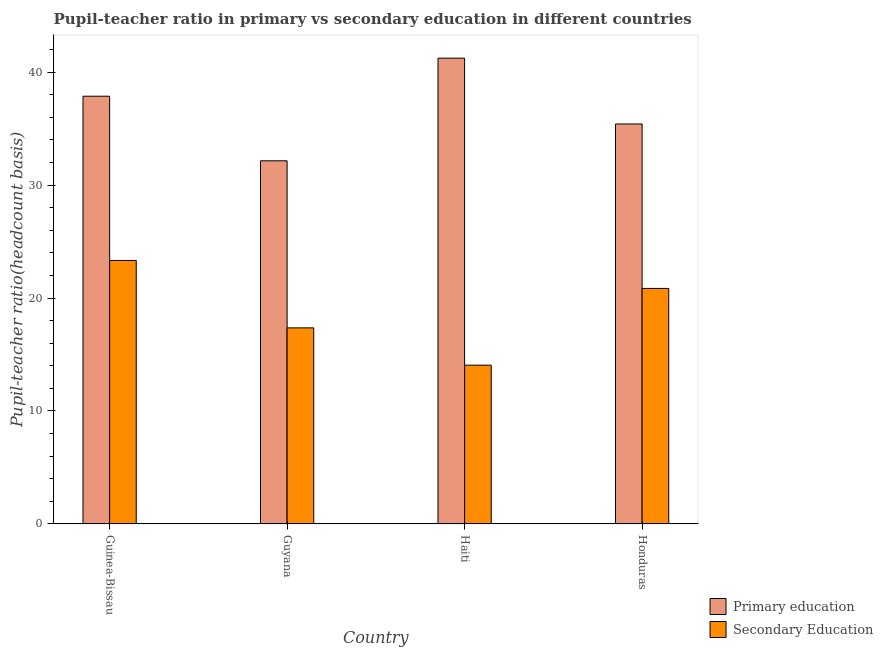How many bars are there on the 3rd tick from the left?
Provide a short and direct response. 2. What is the label of the 3rd group of bars from the left?
Provide a short and direct response. Haiti. In how many cases, is the number of bars for a given country not equal to the number of legend labels?
Provide a succinct answer. 0. What is the pupil-teacher ratio in primary education in Guinea-Bissau?
Provide a succinct answer. 37.86. Across all countries, what is the maximum pupil teacher ratio on secondary education?
Provide a short and direct response. 23.32. Across all countries, what is the minimum pupil teacher ratio on secondary education?
Offer a terse response. 14.06. In which country was the pupil teacher ratio on secondary education maximum?
Offer a terse response. Guinea-Bissau. In which country was the pupil teacher ratio on secondary education minimum?
Keep it short and to the point. Haiti. What is the total pupil-teacher ratio in primary education in the graph?
Ensure brevity in your answer.  146.63. What is the difference between the pupil teacher ratio on secondary education in Guinea-Bissau and that in Haiti?
Offer a very short reply. 9.27. What is the difference between the pupil-teacher ratio in primary education in Guyana and the pupil teacher ratio on secondary education in Honduras?
Provide a succinct answer. 11.29. What is the average pupil-teacher ratio in primary education per country?
Ensure brevity in your answer.  36.66. What is the difference between the pupil-teacher ratio in primary education and pupil teacher ratio on secondary education in Guyana?
Your response must be concise. 14.79. In how many countries, is the pupil teacher ratio on secondary education greater than 34 ?
Your answer should be compact. 0. What is the ratio of the pupil teacher ratio on secondary education in Guinea-Bissau to that in Haiti?
Keep it short and to the point. 1.66. Is the pupil teacher ratio on secondary education in Haiti less than that in Honduras?
Your answer should be very brief. Yes. What is the difference between the highest and the second highest pupil teacher ratio on secondary education?
Give a very brief answer. 2.47. What is the difference between the highest and the lowest pupil teacher ratio on secondary education?
Provide a short and direct response. 9.27. In how many countries, is the pupil teacher ratio on secondary education greater than the average pupil teacher ratio on secondary education taken over all countries?
Offer a very short reply. 2. Is the sum of the pupil teacher ratio on secondary education in Guyana and Haiti greater than the maximum pupil-teacher ratio in primary education across all countries?
Give a very brief answer. No. What does the 1st bar from the right in Haiti represents?
Keep it short and to the point. Secondary Education. How many bars are there?
Offer a very short reply. 8. How many countries are there in the graph?
Ensure brevity in your answer.  4. Are the values on the major ticks of Y-axis written in scientific E-notation?
Your answer should be compact. No. Does the graph contain any zero values?
Keep it short and to the point. No. Where does the legend appear in the graph?
Provide a succinct answer. Bottom right. How are the legend labels stacked?
Provide a short and direct response. Vertical. What is the title of the graph?
Give a very brief answer. Pupil-teacher ratio in primary vs secondary education in different countries. Does "Secondary education" appear as one of the legend labels in the graph?
Your answer should be compact. No. What is the label or title of the Y-axis?
Your response must be concise. Pupil-teacher ratio(headcount basis). What is the Pupil-teacher ratio(headcount basis) of Primary education in Guinea-Bissau?
Provide a succinct answer. 37.86. What is the Pupil-teacher ratio(headcount basis) in Secondary Education in Guinea-Bissau?
Offer a very short reply. 23.32. What is the Pupil-teacher ratio(headcount basis) of Primary education in Guyana?
Make the answer very short. 32.14. What is the Pupil-teacher ratio(headcount basis) in Secondary Education in Guyana?
Your answer should be compact. 17.36. What is the Pupil-teacher ratio(headcount basis) of Primary education in Haiti?
Offer a very short reply. 41.23. What is the Pupil-teacher ratio(headcount basis) of Secondary Education in Haiti?
Ensure brevity in your answer.  14.06. What is the Pupil-teacher ratio(headcount basis) of Primary education in Honduras?
Make the answer very short. 35.4. What is the Pupil-teacher ratio(headcount basis) of Secondary Education in Honduras?
Ensure brevity in your answer.  20.85. Across all countries, what is the maximum Pupil-teacher ratio(headcount basis) of Primary education?
Make the answer very short. 41.23. Across all countries, what is the maximum Pupil-teacher ratio(headcount basis) in Secondary Education?
Your answer should be very brief. 23.32. Across all countries, what is the minimum Pupil-teacher ratio(headcount basis) of Primary education?
Give a very brief answer. 32.14. Across all countries, what is the minimum Pupil-teacher ratio(headcount basis) in Secondary Education?
Make the answer very short. 14.06. What is the total Pupil-teacher ratio(headcount basis) of Primary education in the graph?
Offer a terse response. 146.63. What is the total Pupil-teacher ratio(headcount basis) of Secondary Education in the graph?
Provide a short and direct response. 75.58. What is the difference between the Pupil-teacher ratio(headcount basis) in Primary education in Guinea-Bissau and that in Guyana?
Make the answer very short. 5.72. What is the difference between the Pupil-teacher ratio(headcount basis) of Secondary Education in Guinea-Bissau and that in Guyana?
Offer a terse response. 5.97. What is the difference between the Pupil-teacher ratio(headcount basis) of Primary education in Guinea-Bissau and that in Haiti?
Your response must be concise. -3.37. What is the difference between the Pupil-teacher ratio(headcount basis) of Secondary Education in Guinea-Bissau and that in Haiti?
Keep it short and to the point. 9.27. What is the difference between the Pupil-teacher ratio(headcount basis) of Primary education in Guinea-Bissau and that in Honduras?
Ensure brevity in your answer.  2.46. What is the difference between the Pupil-teacher ratio(headcount basis) in Secondary Education in Guinea-Bissau and that in Honduras?
Provide a short and direct response. 2.47. What is the difference between the Pupil-teacher ratio(headcount basis) of Primary education in Guyana and that in Haiti?
Offer a terse response. -9.08. What is the difference between the Pupil-teacher ratio(headcount basis) of Secondary Education in Guyana and that in Haiti?
Provide a succinct answer. 3.3. What is the difference between the Pupil-teacher ratio(headcount basis) in Primary education in Guyana and that in Honduras?
Your answer should be compact. -3.26. What is the difference between the Pupil-teacher ratio(headcount basis) of Secondary Education in Guyana and that in Honduras?
Provide a short and direct response. -3.49. What is the difference between the Pupil-teacher ratio(headcount basis) in Primary education in Haiti and that in Honduras?
Provide a short and direct response. 5.82. What is the difference between the Pupil-teacher ratio(headcount basis) of Secondary Education in Haiti and that in Honduras?
Your response must be concise. -6.79. What is the difference between the Pupil-teacher ratio(headcount basis) in Primary education in Guinea-Bissau and the Pupil-teacher ratio(headcount basis) in Secondary Education in Guyana?
Your response must be concise. 20.5. What is the difference between the Pupil-teacher ratio(headcount basis) in Primary education in Guinea-Bissau and the Pupil-teacher ratio(headcount basis) in Secondary Education in Haiti?
Provide a short and direct response. 23.8. What is the difference between the Pupil-teacher ratio(headcount basis) in Primary education in Guinea-Bissau and the Pupil-teacher ratio(headcount basis) in Secondary Education in Honduras?
Your answer should be compact. 17.01. What is the difference between the Pupil-teacher ratio(headcount basis) of Primary education in Guyana and the Pupil-teacher ratio(headcount basis) of Secondary Education in Haiti?
Make the answer very short. 18.09. What is the difference between the Pupil-teacher ratio(headcount basis) of Primary education in Guyana and the Pupil-teacher ratio(headcount basis) of Secondary Education in Honduras?
Give a very brief answer. 11.29. What is the difference between the Pupil-teacher ratio(headcount basis) in Primary education in Haiti and the Pupil-teacher ratio(headcount basis) in Secondary Education in Honduras?
Offer a very short reply. 20.38. What is the average Pupil-teacher ratio(headcount basis) of Primary education per country?
Provide a short and direct response. 36.66. What is the average Pupil-teacher ratio(headcount basis) in Secondary Education per country?
Provide a succinct answer. 18.9. What is the difference between the Pupil-teacher ratio(headcount basis) in Primary education and Pupil-teacher ratio(headcount basis) in Secondary Education in Guinea-Bissau?
Make the answer very short. 14.54. What is the difference between the Pupil-teacher ratio(headcount basis) in Primary education and Pupil-teacher ratio(headcount basis) in Secondary Education in Guyana?
Your answer should be compact. 14.79. What is the difference between the Pupil-teacher ratio(headcount basis) of Primary education and Pupil-teacher ratio(headcount basis) of Secondary Education in Haiti?
Offer a terse response. 27.17. What is the difference between the Pupil-teacher ratio(headcount basis) of Primary education and Pupil-teacher ratio(headcount basis) of Secondary Education in Honduras?
Provide a succinct answer. 14.56. What is the ratio of the Pupil-teacher ratio(headcount basis) of Primary education in Guinea-Bissau to that in Guyana?
Offer a terse response. 1.18. What is the ratio of the Pupil-teacher ratio(headcount basis) in Secondary Education in Guinea-Bissau to that in Guyana?
Your answer should be compact. 1.34. What is the ratio of the Pupil-teacher ratio(headcount basis) in Primary education in Guinea-Bissau to that in Haiti?
Your answer should be compact. 0.92. What is the ratio of the Pupil-teacher ratio(headcount basis) of Secondary Education in Guinea-Bissau to that in Haiti?
Provide a succinct answer. 1.66. What is the ratio of the Pupil-teacher ratio(headcount basis) in Primary education in Guinea-Bissau to that in Honduras?
Provide a short and direct response. 1.07. What is the ratio of the Pupil-teacher ratio(headcount basis) of Secondary Education in Guinea-Bissau to that in Honduras?
Your answer should be compact. 1.12. What is the ratio of the Pupil-teacher ratio(headcount basis) of Primary education in Guyana to that in Haiti?
Your answer should be very brief. 0.78. What is the ratio of the Pupil-teacher ratio(headcount basis) in Secondary Education in Guyana to that in Haiti?
Give a very brief answer. 1.23. What is the ratio of the Pupil-teacher ratio(headcount basis) in Primary education in Guyana to that in Honduras?
Provide a short and direct response. 0.91. What is the ratio of the Pupil-teacher ratio(headcount basis) of Secondary Education in Guyana to that in Honduras?
Give a very brief answer. 0.83. What is the ratio of the Pupil-teacher ratio(headcount basis) in Primary education in Haiti to that in Honduras?
Your response must be concise. 1.16. What is the ratio of the Pupil-teacher ratio(headcount basis) of Secondary Education in Haiti to that in Honduras?
Keep it short and to the point. 0.67. What is the difference between the highest and the second highest Pupil-teacher ratio(headcount basis) of Primary education?
Provide a succinct answer. 3.37. What is the difference between the highest and the second highest Pupil-teacher ratio(headcount basis) in Secondary Education?
Give a very brief answer. 2.47. What is the difference between the highest and the lowest Pupil-teacher ratio(headcount basis) in Primary education?
Make the answer very short. 9.08. What is the difference between the highest and the lowest Pupil-teacher ratio(headcount basis) in Secondary Education?
Offer a very short reply. 9.27. 